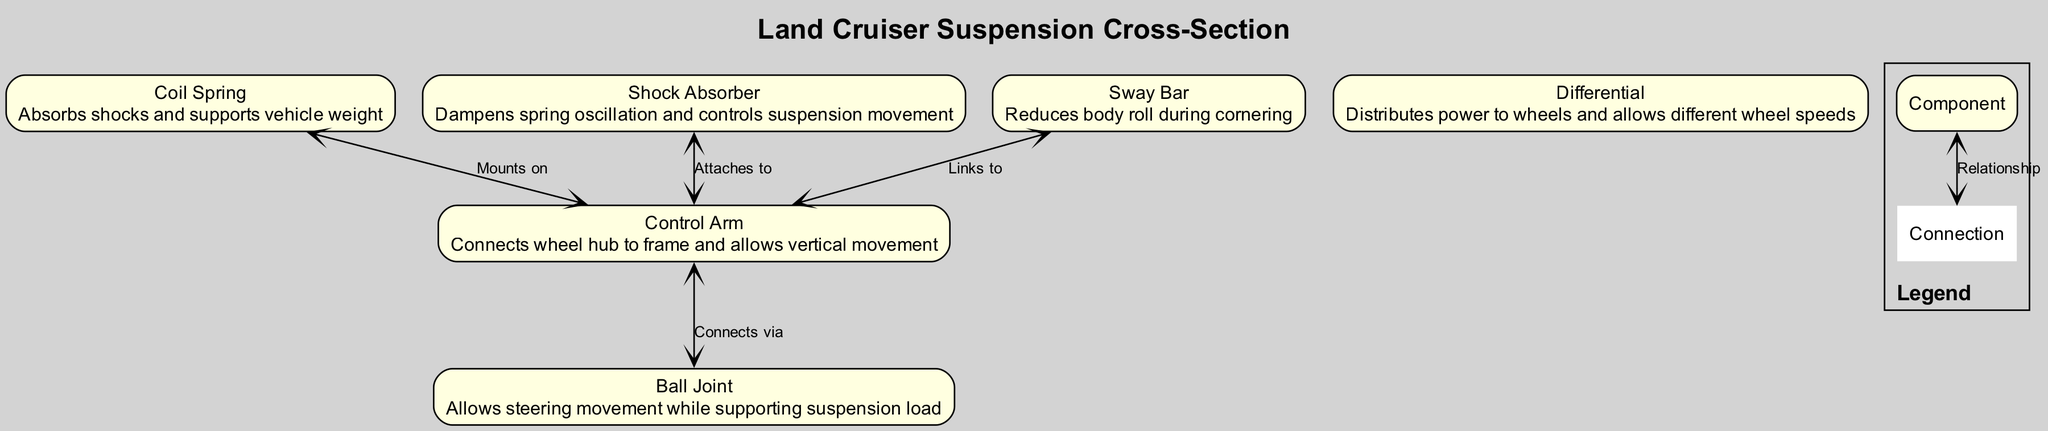What is the function of the Coil Spring? The diagram indicates that the Coil Spring's function is to absorb shocks and support vehicle weight. This information is directly stated in the node for Coil Spring.
Answer: Absorbs shocks and supports vehicle weight Which component connects to the Control Arm with the Sway Bar? The diagram shows that the Sway Bar links to the Control Arm, indicating a direct connection between these two components.
Answer: Links to How many components are there in the diagram? By counting the nodes listed in the components section of the diagram, we find there are six components: Coil Spring, Shock Absorber, Control Arm, Ball Joint, Sway Bar, and Differential.
Answer: 6 What does the Shock Absorber do? The diagram specifies that the Shock Absorber dampens spring oscillation and controls suspension movement, which directly describes its function.
Answer: Dampens spring oscillation and controls suspension movement Which component is responsible for reducing body roll during cornering? According to the diagram, the Sway Bar is mentioned as the component that reduces body roll during cornering, thus fulfilling this role.
Answer: Sway Bar How many connections link the Control Arm to other components? The diagram indicates that the Control Arm has three connections: one to the Coil Spring, one to the Shock Absorber, and one to the Ball Joint, totaling three connections.
Answer: 3 What type of movement does the Ball Joint allow? The diagram states that the Ball Joint allows steering movement while supporting suspension load, clearly defining its function in terms of movement.
Answer: Steering movement Which component distributes power to the wheels? The diagram identifies the Differential as the component that distributes power to the wheels and allows different wheel speeds, reflecting its critical role in the system.
Answer: Differential What connects the Control Arm to the Ball Joint? The diagram shows that the connection between the Control Arm and the Ball Joint occurs via the specified path, which is stated as "Connects via" in the diagram.
Answer: Connects via 